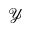Convert formula to latex. <formula><loc_0><loc_0><loc_500><loc_500>\mathcal { Y }</formula> 